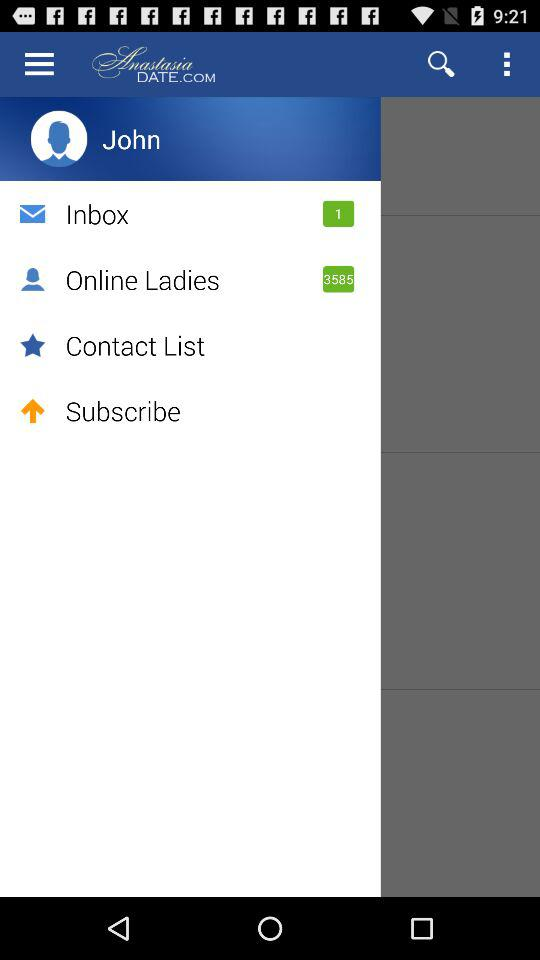What is the name of the user? The name of the user is John. 